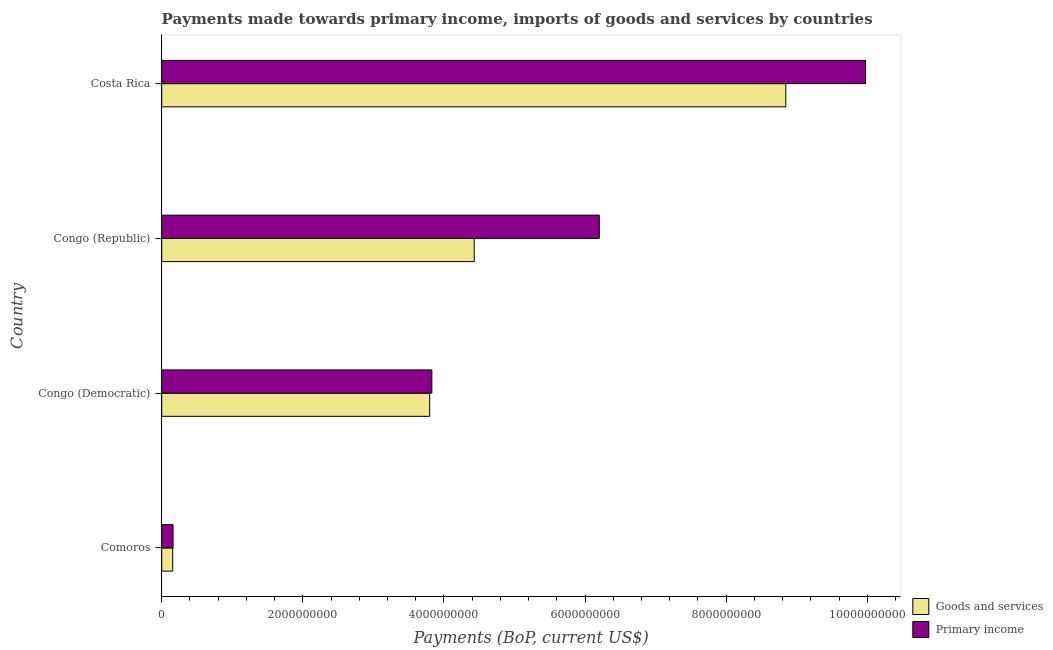How many different coloured bars are there?
Keep it short and to the point. 2. In how many cases, is the number of bars for a given country not equal to the number of legend labels?
Offer a terse response. 0. What is the payments made towards goods and services in Congo (Democratic)?
Give a very brief answer. 3.80e+09. Across all countries, what is the maximum payments made towards primary income?
Provide a succinct answer. 9.98e+09. Across all countries, what is the minimum payments made towards primary income?
Provide a succinct answer. 1.61e+08. In which country was the payments made towards primary income maximum?
Offer a very short reply. Costa Rica. In which country was the payments made towards primary income minimum?
Your response must be concise. Comoros. What is the total payments made towards goods and services in the graph?
Your answer should be very brief. 1.72e+1. What is the difference between the payments made towards goods and services in Congo (Republic) and that in Costa Rica?
Ensure brevity in your answer.  -4.42e+09. What is the difference between the payments made towards goods and services in Costa Rica and the payments made towards primary income in Congo (Democratic)?
Your answer should be compact. 5.02e+09. What is the average payments made towards goods and services per country?
Offer a terse response. 4.31e+09. What is the difference between the payments made towards primary income and payments made towards goods and services in Congo (Democratic)?
Ensure brevity in your answer.  3.15e+07. In how many countries, is the payments made towards primary income greater than 400000000 US$?
Your answer should be very brief. 3. What is the ratio of the payments made towards goods and services in Congo (Republic) to that in Costa Rica?
Ensure brevity in your answer.  0.5. Is the difference between the payments made towards primary income in Congo (Democratic) and Costa Rica greater than the difference between the payments made towards goods and services in Congo (Democratic) and Costa Rica?
Your answer should be compact. No. What is the difference between the highest and the second highest payments made towards goods and services?
Give a very brief answer. 4.42e+09. What is the difference between the highest and the lowest payments made towards goods and services?
Provide a short and direct response. 8.69e+09. In how many countries, is the payments made towards primary income greater than the average payments made towards primary income taken over all countries?
Your answer should be compact. 2. Is the sum of the payments made towards goods and services in Comoros and Congo (Republic) greater than the maximum payments made towards primary income across all countries?
Ensure brevity in your answer.  No. What does the 2nd bar from the top in Comoros represents?
Make the answer very short. Goods and services. What does the 2nd bar from the bottom in Congo (Republic) represents?
Provide a succinct answer. Primary income. How many countries are there in the graph?
Keep it short and to the point. 4. Does the graph contain any zero values?
Provide a succinct answer. No. Where does the legend appear in the graph?
Provide a short and direct response. Bottom right. How many legend labels are there?
Your answer should be compact. 2. What is the title of the graph?
Provide a short and direct response. Payments made towards primary income, imports of goods and services by countries. Does "Nitrous oxide emissions" appear as one of the legend labels in the graph?
Your answer should be compact. No. What is the label or title of the X-axis?
Give a very brief answer. Payments (BoP, current US$). What is the Payments (BoP, current US$) of Goods and services in Comoros?
Offer a terse response. 1.56e+08. What is the Payments (BoP, current US$) of Primary income in Comoros?
Ensure brevity in your answer.  1.61e+08. What is the Payments (BoP, current US$) of Goods and services in Congo (Democratic)?
Offer a very short reply. 3.80e+09. What is the Payments (BoP, current US$) of Primary income in Congo (Democratic)?
Make the answer very short. 3.83e+09. What is the Payments (BoP, current US$) of Goods and services in Congo (Republic)?
Provide a succinct answer. 4.43e+09. What is the Payments (BoP, current US$) in Primary income in Congo (Republic)?
Offer a terse response. 6.20e+09. What is the Payments (BoP, current US$) of Goods and services in Costa Rica?
Keep it short and to the point. 8.85e+09. What is the Payments (BoP, current US$) in Primary income in Costa Rica?
Give a very brief answer. 9.98e+09. Across all countries, what is the maximum Payments (BoP, current US$) in Goods and services?
Your answer should be compact. 8.85e+09. Across all countries, what is the maximum Payments (BoP, current US$) in Primary income?
Keep it short and to the point. 9.98e+09. Across all countries, what is the minimum Payments (BoP, current US$) of Goods and services?
Give a very brief answer. 1.56e+08. Across all countries, what is the minimum Payments (BoP, current US$) in Primary income?
Give a very brief answer. 1.61e+08. What is the total Payments (BoP, current US$) of Goods and services in the graph?
Your response must be concise. 1.72e+1. What is the total Payments (BoP, current US$) in Primary income in the graph?
Ensure brevity in your answer.  2.02e+1. What is the difference between the Payments (BoP, current US$) of Goods and services in Comoros and that in Congo (Democratic)?
Provide a succinct answer. -3.64e+09. What is the difference between the Payments (BoP, current US$) in Primary income in Comoros and that in Congo (Democratic)?
Keep it short and to the point. -3.67e+09. What is the difference between the Payments (BoP, current US$) of Goods and services in Comoros and that in Congo (Republic)?
Ensure brevity in your answer.  -4.27e+09. What is the difference between the Payments (BoP, current US$) of Primary income in Comoros and that in Congo (Republic)?
Make the answer very short. -6.04e+09. What is the difference between the Payments (BoP, current US$) in Goods and services in Comoros and that in Costa Rica?
Give a very brief answer. -8.69e+09. What is the difference between the Payments (BoP, current US$) in Primary income in Comoros and that in Costa Rica?
Your answer should be compact. -9.82e+09. What is the difference between the Payments (BoP, current US$) of Goods and services in Congo (Democratic) and that in Congo (Republic)?
Keep it short and to the point. -6.32e+08. What is the difference between the Payments (BoP, current US$) of Primary income in Congo (Democratic) and that in Congo (Republic)?
Your answer should be compact. -2.37e+09. What is the difference between the Payments (BoP, current US$) of Goods and services in Congo (Democratic) and that in Costa Rica?
Keep it short and to the point. -5.05e+09. What is the difference between the Payments (BoP, current US$) of Primary income in Congo (Democratic) and that in Costa Rica?
Offer a very short reply. -6.15e+09. What is the difference between the Payments (BoP, current US$) in Goods and services in Congo (Republic) and that in Costa Rica?
Provide a succinct answer. -4.42e+09. What is the difference between the Payments (BoP, current US$) in Primary income in Congo (Republic) and that in Costa Rica?
Your response must be concise. -3.77e+09. What is the difference between the Payments (BoP, current US$) in Goods and services in Comoros and the Payments (BoP, current US$) in Primary income in Congo (Democratic)?
Your answer should be compact. -3.67e+09. What is the difference between the Payments (BoP, current US$) in Goods and services in Comoros and the Payments (BoP, current US$) in Primary income in Congo (Republic)?
Offer a terse response. -6.05e+09. What is the difference between the Payments (BoP, current US$) in Goods and services in Comoros and the Payments (BoP, current US$) in Primary income in Costa Rica?
Your response must be concise. -9.82e+09. What is the difference between the Payments (BoP, current US$) of Goods and services in Congo (Democratic) and the Payments (BoP, current US$) of Primary income in Congo (Republic)?
Ensure brevity in your answer.  -2.40e+09. What is the difference between the Payments (BoP, current US$) in Goods and services in Congo (Democratic) and the Payments (BoP, current US$) in Primary income in Costa Rica?
Offer a terse response. -6.18e+09. What is the difference between the Payments (BoP, current US$) in Goods and services in Congo (Republic) and the Payments (BoP, current US$) in Primary income in Costa Rica?
Provide a succinct answer. -5.55e+09. What is the average Payments (BoP, current US$) in Goods and services per country?
Give a very brief answer. 4.31e+09. What is the average Payments (BoP, current US$) in Primary income per country?
Offer a terse response. 5.04e+09. What is the difference between the Payments (BoP, current US$) in Goods and services and Payments (BoP, current US$) in Primary income in Comoros?
Ensure brevity in your answer.  -5.06e+06. What is the difference between the Payments (BoP, current US$) in Goods and services and Payments (BoP, current US$) in Primary income in Congo (Democratic)?
Give a very brief answer. -3.15e+07. What is the difference between the Payments (BoP, current US$) of Goods and services and Payments (BoP, current US$) of Primary income in Congo (Republic)?
Offer a very short reply. -1.77e+09. What is the difference between the Payments (BoP, current US$) of Goods and services and Payments (BoP, current US$) of Primary income in Costa Rica?
Make the answer very short. -1.13e+09. What is the ratio of the Payments (BoP, current US$) of Goods and services in Comoros to that in Congo (Democratic)?
Provide a succinct answer. 0.04. What is the ratio of the Payments (BoP, current US$) of Primary income in Comoros to that in Congo (Democratic)?
Give a very brief answer. 0.04. What is the ratio of the Payments (BoP, current US$) of Goods and services in Comoros to that in Congo (Republic)?
Your response must be concise. 0.04. What is the ratio of the Payments (BoP, current US$) of Primary income in Comoros to that in Congo (Republic)?
Ensure brevity in your answer.  0.03. What is the ratio of the Payments (BoP, current US$) of Goods and services in Comoros to that in Costa Rica?
Offer a terse response. 0.02. What is the ratio of the Payments (BoP, current US$) in Primary income in Comoros to that in Costa Rica?
Give a very brief answer. 0.02. What is the ratio of the Payments (BoP, current US$) in Goods and services in Congo (Democratic) to that in Congo (Republic)?
Provide a succinct answer. 0.86. What is the ratio of the Payments (BoP, current US$) of Primary income in Congo (Democratic) to that in Congo (Republic)?
Give a very brief answer. 0.62. What is the ratio of the Payments (BoP, current US$) in Goods and services in Congo (Democratic) to that in Costa Rica?
Keep it short and to the point. 0.43. What is the ratio of the Payments (BoP, current US$) in Primary income in Congo (Democratic) to that in Costa Rica?
Give a very brief answer. 0.38. What is the ratio of the Payments (BoP, current US$) of Goods and services in Congo (Republic) to that in Costa Rica?
Keep it short and to the point. 0.5. What is the ratio of the Payments (BoP, current US$) of Primary income in Congo (Republic) to that in Costa Rica?
Give a very brief answer. 0.62. What is the difference between the highest and the second highest Payments (BoP, current US$) in Goods and services?
Offer a terse response. 4.42e+09. What is the difference between the highest and the second highest Payments (BoP, current US$) in Primary income?
Provide a short and direct response. 3.77e+09. What is the difference between the highest and the lowest Payments (BoP, current US$) of Goods and services?
Provide a succinct answer. 8.69e+09. What is the difference between the highest and the lowest Payments (BoP, current US$) of Primary income?
Offer a terse response. 9.82e+09. 